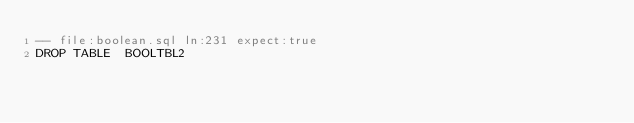<code> <loc_0><loc_0><loc_500><loc_500><_SQL_>-- file:boolean.sql ln:231 expect:true
DROP TABLE  BOOLTBL2
</code> 